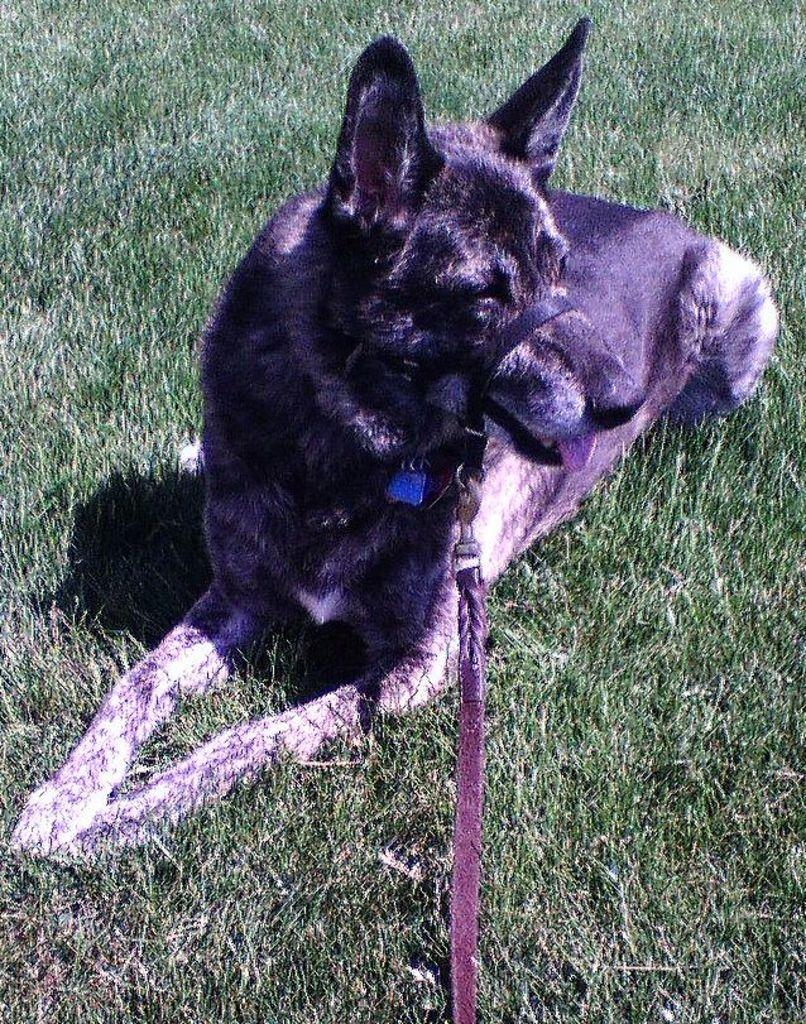What animal is present in the image? There is a dog in the image. Where is the dog located? The dog is on the grass. What is attached to the dog's nose? There is a belt on the dog's nose. How is the dog being controlled or guided in the image? A leash is tied to the belt. What type of basketball trick is the dog performing in the image? There is no basketball or trick present in the image; it features a dog with a belt and leash on the grass. 